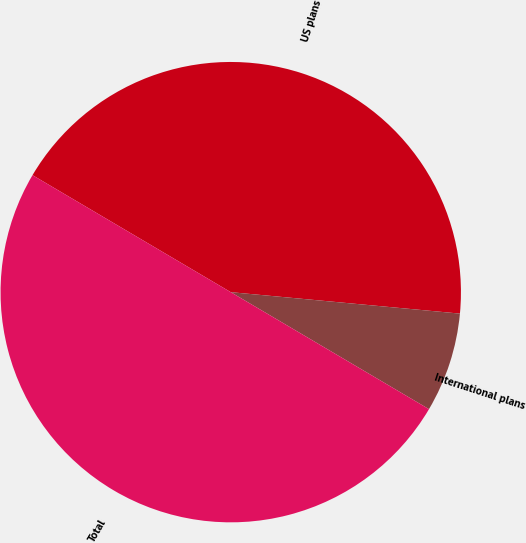Convert chart. <chart><loc_0><loc_0><loc_500><loc_500><pie_chart><fcel>US plans<fcel>International plans<fcel>Total<nl><fcel>43.0%<fcel>7.0%<fcel>50.0%<nl></chart> 